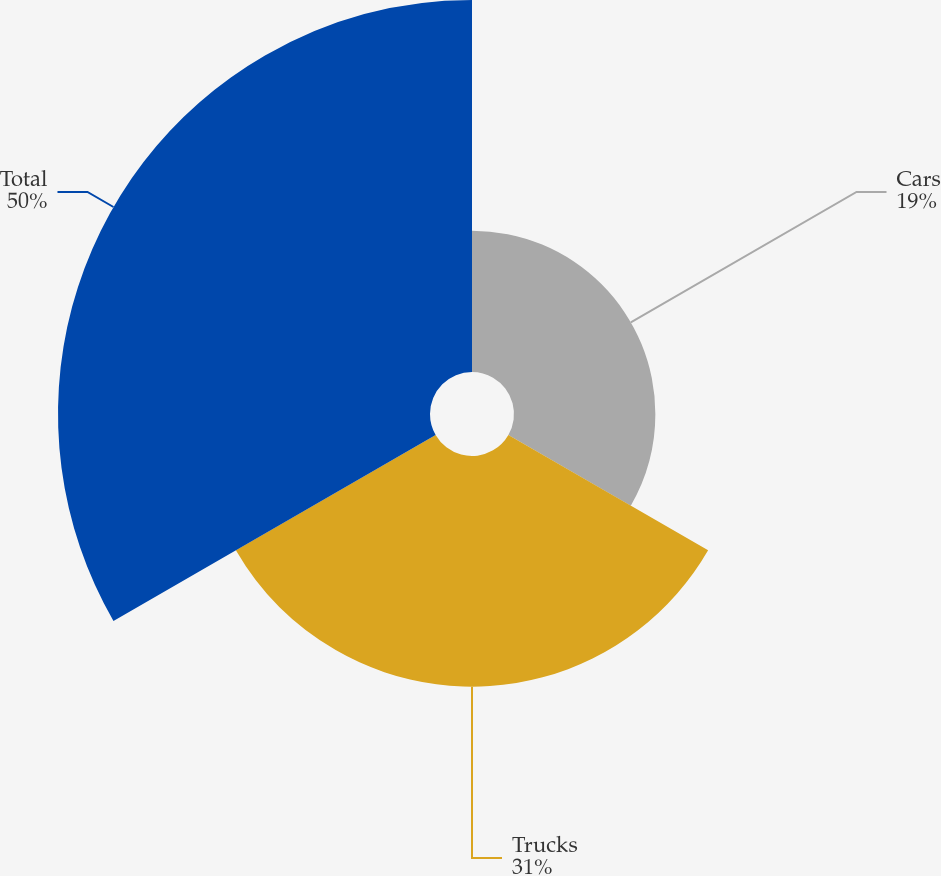Convert chart. <chart><loc_0><loc_0><loc_500><loc_500><pie_chart><fcel>Cars<fcel>Trucks<fcel>Total<nl><fcel>19.0%<fcel>31.0%<fcel>50.0%<nl></chart> 